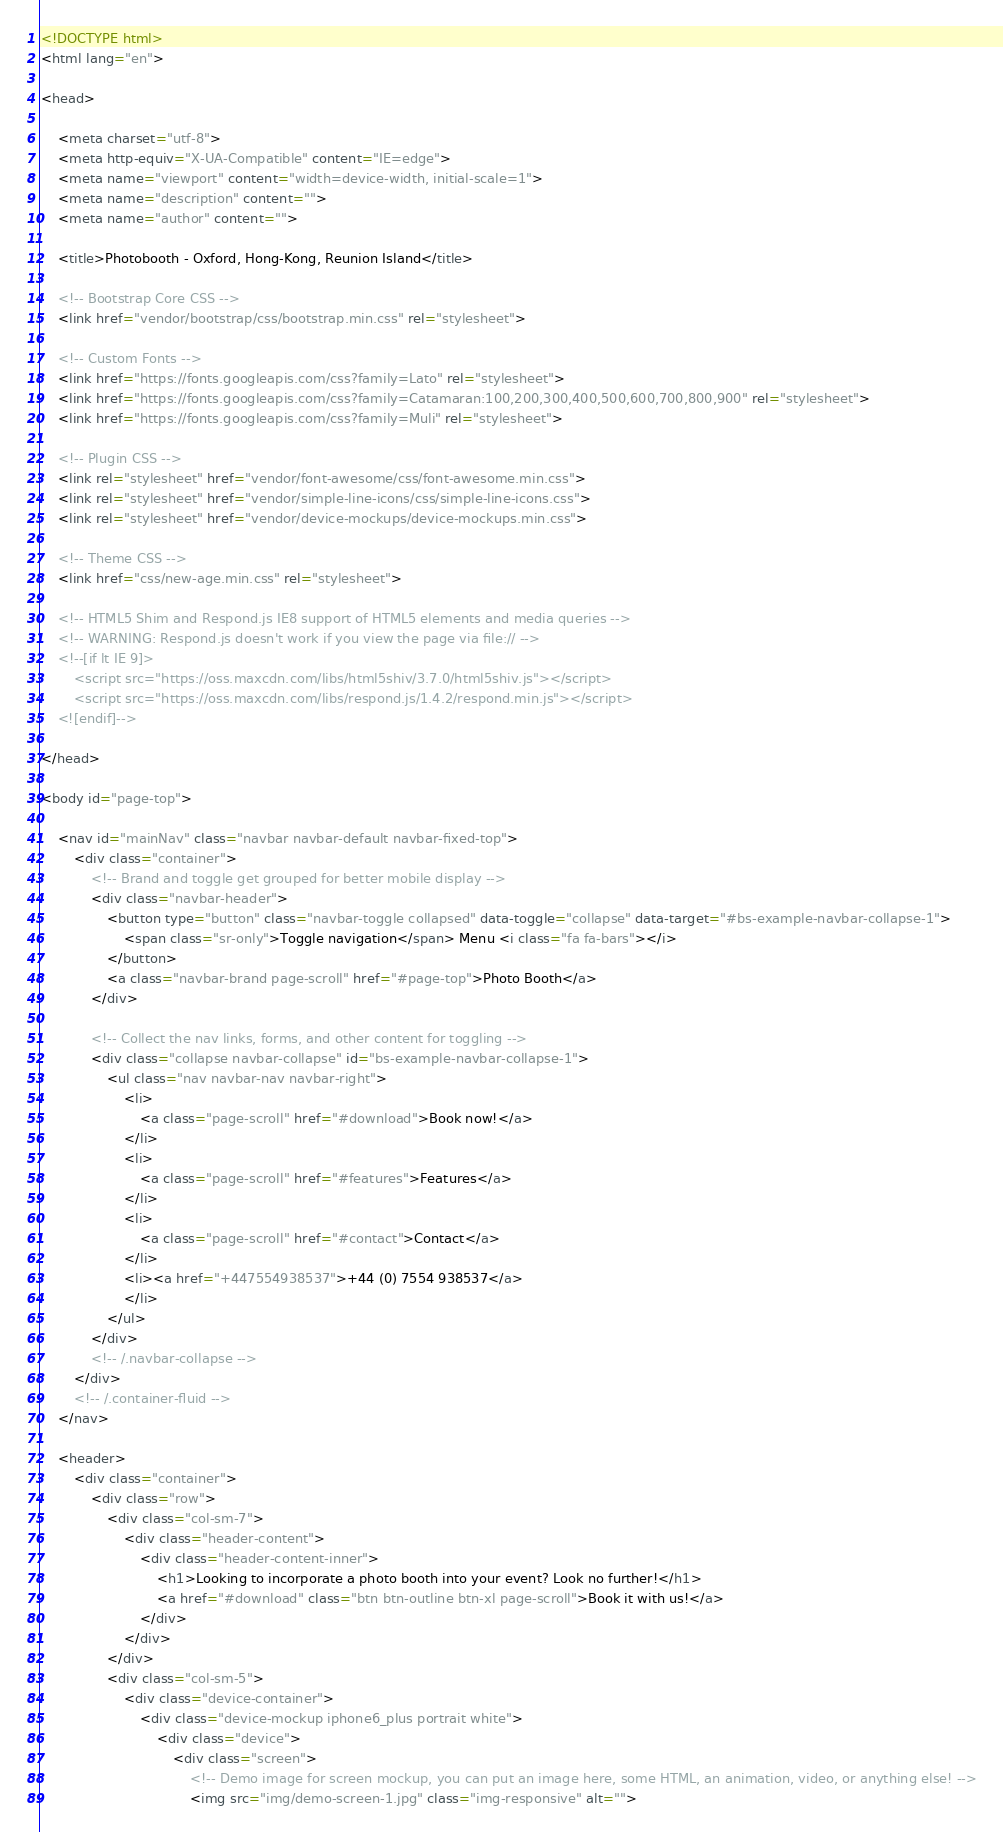<code> <loc_0><loc_0><loc_500><loc_500><_HTML_><!DOCTYPE html>
<html lang="en">

<head>

    <meta charset="utf-8">
    <meta http-equiv="X-UA-Compatible" content="IE=edge">
    <meta name="viewport" content="width=device-width, initial-scale=1">
    <meta name="description" content="">
    <meta name="author" content="">

    <title>Photobooth - Oxford, Hong-Kong, Reunion Island</title>

    <!-- Bootstrap Core CSS -->
    <link href="vendor/bootstrap/css/bootstrap.min.css" rel="stylesheet">

    <!-- Custom Fonts -->
    <link href="https://fonts.googleapis.com/css?family=Lato" rel="stylesheet">
    <link href="https://fonts.googleapis.com/css?family=Catamaran:100,200,300,400,500,600,700,800,900" rel="stylesheet">
    <link href="https://fonts.googleapis.com/css?family=Muli" rel="stylesheet">

    <!-- Plugin CSS -->
    <link rel="stylesheet" href="vendor/font-awesome/css/font-awesome.min.css">
    <link rel="stylesheet" href="vendor/simple-line-icons/css/simple-line-icons.css">
    <link rel="stylesheet" href="vendor/device-mockups/device-mockups.min.css">

    <!-- Theme CSS -->
    <link href="css/new-age.min.css" rel="stylesheet">

    <!-- HTML5 Shim and Respond.js IE8 support of HTML5 elements and media queries -->
    <!-- WARNING: Respond.js doesn't work if you view the page via file:// -->
    <!--[if lt IE 9]>
        <script src="https://oss.maxcdn.com/libs/html5shiv/3.7.0/html5shiv.js"></script>
        <script src="https://oss.maxcdn.com/libs/respond.js/1.4.2/respond.min.js"></script>
    <![endif]-->

</head>

<body id="page-top">

    <nav id="mainNav" class="navbar navbar-default navbar-fixed-top">
        <div class="container">
            <!-- Brand and toggle get grouped for better mobile display -->
            <div class="navbar-header">
                <button type="button" class="navbar-toggle collapsed" data-toggle="collapse" data-target="#bs-example-navbar-collapse-1">
                    <span class="sr-only">Toggle navigation</span> Menu <i class="fa fa-bars"></i>
                </button>
                <a class="navbar-brand page-scroll" href="#page-top">Photo Booth</a>
            </div>

            <!-- Collect the nav links, forms, and other content for toggling -->
            <div class="collapse navbar-collapse" id="bs-example-navbar-collapse-1">
                <ul class="nav navbar-nav navbar-right">
                    <li>
                        <a class="page-scroll" href="#download">Book now!</a>
                    </li>
                    <li>
                        <a class="page-scroll" href="#features">Features</a>
                    </li>
                    <li>
                        <a class="page-scroll" href="#contact">Contact</a>
                    </li>
                    <li><a href="+447554938537">+44 (0) 7554 938537</a>
                    </li>
                </ul>
            </div>
            <!-- /.navbar-collapse -->
        </div>
        <!-- /.container-fluid -->
    </nav>

    <header>
        <div class="container">
            <div class="row">
                <div class="col-sm-7">
                    <div class="header-content">
                        <div class="header-content-inner">
                            <h1>Looking to incorporate a photo booth into your event? Look no further!</h1>
                            <a href="#download" class="btn btn-outline btn-xl page-scroll">Book it with us!</a>
                        </div>
                    </div>
                </div>
                <div class="col-sm-5">
                    <div class="device-container">
                        <div class="device-mockup iphone6_plus portrait white">
                            <div class="device">
                                <div class="screen">
                                    <!-- Demo image for screen mockup, you can put an image here, some HTML, an animation, video, or anything else! -->
                                    <img src="img/demo-screen-1.jpg" class="img-responsive" alt=""></code> 